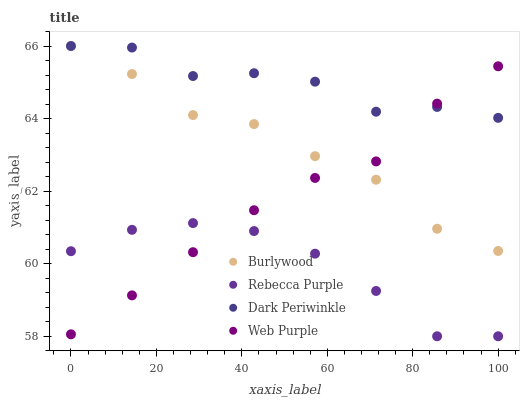Does Rebecca Purple have the minimum area under the curve?
Answer yes or no. Yes. Does Dark Periwinkle have the maximum area under the curve?
Answer yes or no. Yes. Does Web Purple have the minimum area under the curve?
Answer yes or no. No. Does Web Purple have the maximum area under the curve?
Answer yes or no. No. Is Web Purple the smoothest?
Answer yes or no. Yes. Is Dark Periwinkle the roughest?
Answer yes or no. Yes. Is Rebecca Purple the smoothest?
Answer yes or no. No. Is Rebecca Purple the roughest?
Answer yes or no. No. Does Rebecca Purple have the lowest value?
Answer yes or no. Yes. Does Web Purple have the lowest value?
Answer yes or no. No. Does Dark Periwinkle have the highest value?
Answer yes or no. Yes. Does Web Purple have the highest value?
Answer yes or no. No. Is Rebecca Purple less than Burlywood?
Answer yes or no. Yes. Is Dark Periwinkle greater than Rebecca Purple?
Answer yes or no. Yes. Does Burlywood intersect Web Purple?
Answer yes or no. Yes. Is Burlywood less than Web Purple?
Answer yes or no. No. Is Burlywood greater than Web Purple?
Answer yes or no. No. Does Rebecca Purple intersect Burlywood?
Answer yes or no. No. 